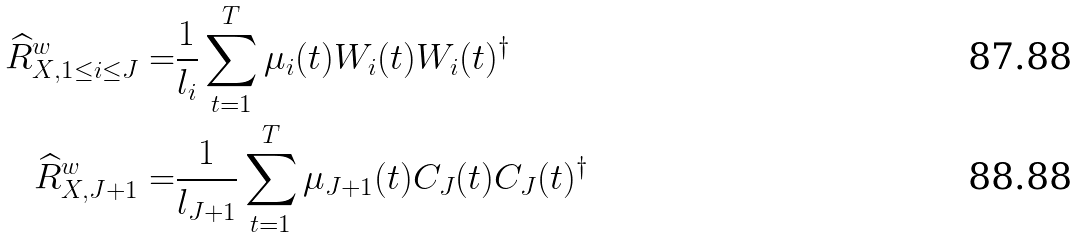Convert formula to latex. <formula><loc_0><loc_0><loc_500><loc_500>\widehat { R } _ { X , 1 \leq i \leq J } ^ { w } = & \frac { 1 } { l _ { i } } \sum _ { t = 1 } ^ { T } \mu _ { i } ( t ) W _ { i } ( t ) W _ { i } ( t ) ^ { \dagger } \\ \widehat { R } _ { X , J + 1 } ^ { w } = & \frac { 1 } { l _ { J + 1 } } \sum _ { t = 1 } ^ { T } \mu _ { J + 1 } ( t ) C _ { J } ( t ) C _ { J } ( t ) ^ { \dagger }</formula> 